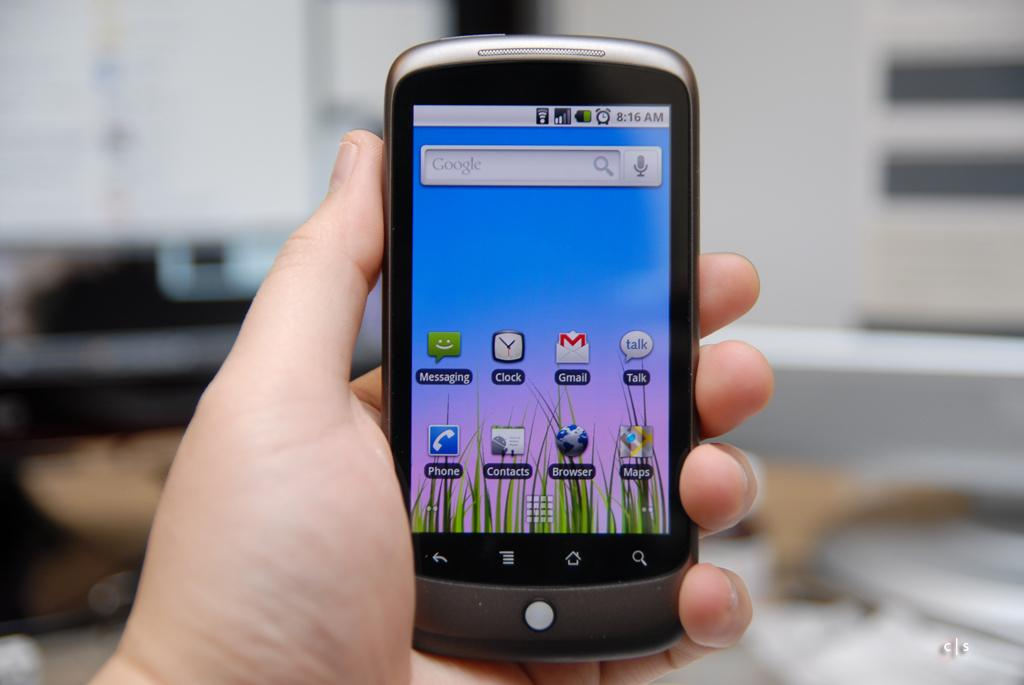Provide a one-sentence caption for the provided image. Left hand holding a large cellphone with Yahoo Gmail and other apps on front of screen. 